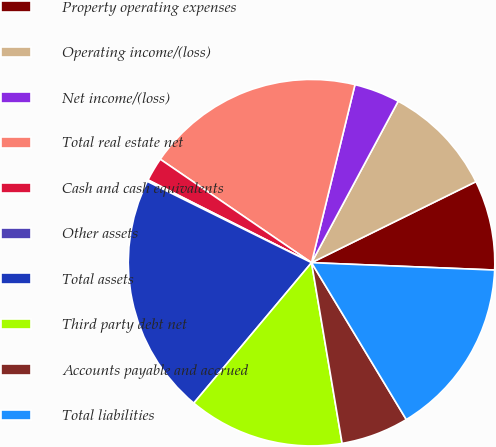Convert chart to OTSL. <chart><loc_0><loc_0><loc_500><loc_500><pie_chart><fcel>Property operating expenses<fcel>Operating income/(loss)<fcel>Net income/(loss)<fcel>Total real estate net<fcel>Cash and cash equivalents<fcel>Other assets<fcel>Total assets<fcel>Third party debt net<fcel>Accounts payable and accrued<fcel>Total liabilities<nl><fcel>7.93%<fcel>9.87%<fcel>4.03%<fcel>19.26%<fcel>2.09%<fcel>0.14%<fcel>21.21%<fcel>13.77%<fcel>5.98%<fcel>15.71%<nl></chart> 